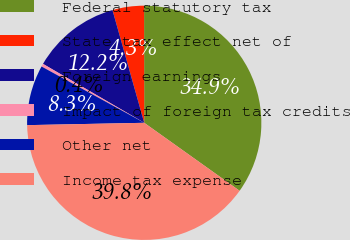<chart> <loc_0><loc_0><loc_500><loc_500><pie_chart><fcel>Federal statutory tax<fcel>State tax effect net of<fcel>Foreign earnings<fcel>Impact of foreign tax credits<fcel>Other net<fcel>Income tax expense<nl><fcel>34.88%<fcel>4.35%<fcel>12.24%<fcel>0.41%<fcel>8.3%<fcel>39.83%<nl></chart> 